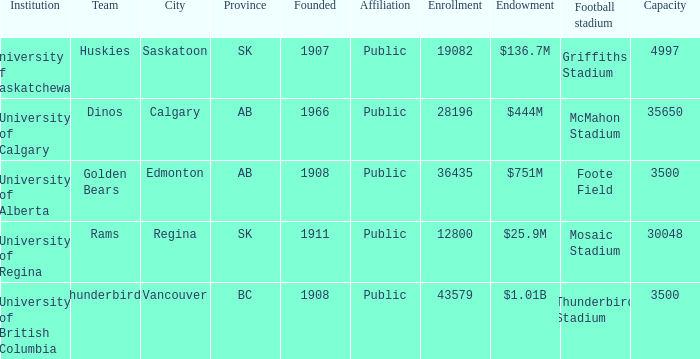How many institutions are shown for the football stadium of mosaic stadium? 1.0. 